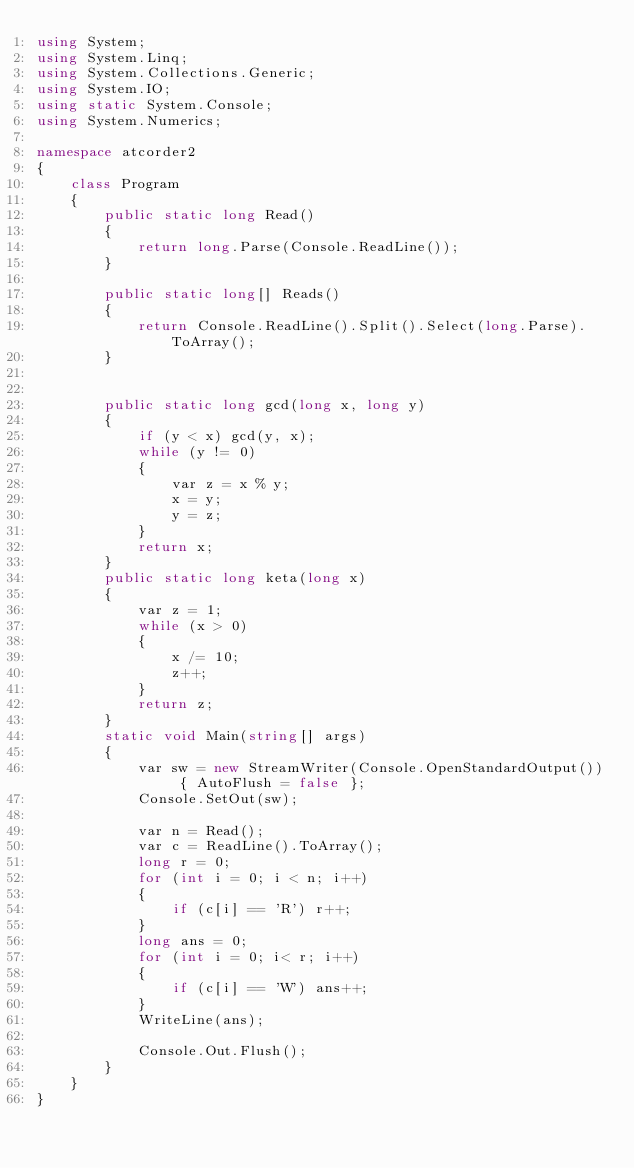Convert code to text. <code><loc_0><loc_0><loc_500><loc_500><_C#_>using System;
using System.Linq;
using System.Collections.Generic;
using System.IO;
using static System.Console;
using System.Numerics;

namespace atcorder2
{
    class Program
    {
        public static long Read()
        {
            return long.Parse(Console.ReadLine());
        }

        public static long[] Reads()
        {
            return Console.ReadLine().Split().Select(long.Parse).ToArray();
        }


        public static long gcd(long x, long y)
        {
            if (y < x) gcd(y, x);
            while (y != 0)
            {
                var z = x % y;
                x = y;
                y = z;
            }
            return x;
        }
        public static long keta(long x)
        {
            var z = 1;
            while (x > 0)
            {
                x /= 10;
                z++;
            }
            return z;
        }
        static void Main(string[] args)
        {
            var sw = new StreamWriter(Console.OpenStandardOutput()) { AutoFlush = false };
            Console.SetOut(sw);

            var n = Read();
            var c = ReadLine().ToArray();
            long r = 0;
            for (int i = 0; i < n; i++)
            {
                if (c[i] == 'R') r++;
            }
            long ans = 0;
            for (int i = 0; i< r; i++)
            {
                if (c[i] == 'W') ans++;
            }
            WriteLine(ans);
          
            Console.Out.Flush();
        }
    }
}

</code> 